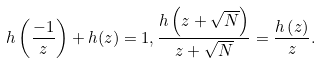Convert formula to latex. <formula><loc_0><loc_0><loc_500><loc_500>h \left ( \frac { - 1 } { z } \right ) + h ( z ) = 1 , \frac { h \left ( z + \sqrt { N } \right ) } { z + \sqrt { N } } = \frac { h \left ( z \right ) } { z } .</formula> 